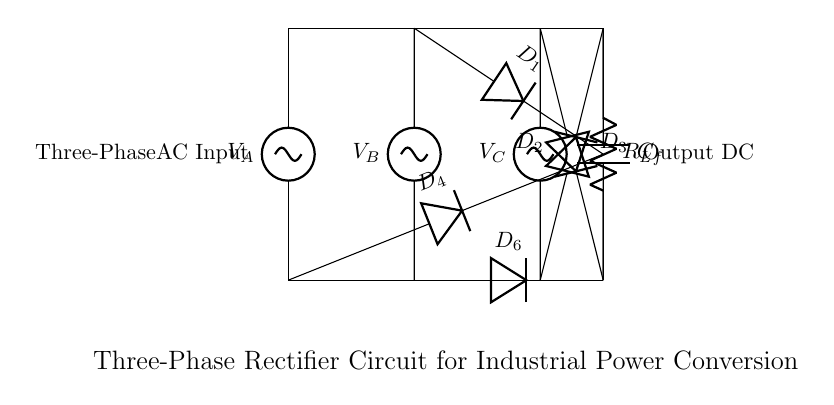What kind of input does this circuit use? The circuit uses a three-phase AC input, as indicated by the three voltage sources labeled V_A, V_B, and V_C.
Answer: three-phase AC input How many diodes are in the circuit? There are six diodes present in the diagram, labeled D_1, D_2, D_3, D_4, D_5, and D_6.
Answer: six diodes What is the primary function of this circuit? The primary function of this circuit is to convert three-phase AC power into DC using a diode bridge rectifier.
Answer: convert AC to DC What is the output component used in this circuit? The output components include a resistor labeled R_L and a capacitor labeled C_f, which are used to filter and deliver the rectified DC voltage.
Answer: R_L and C_f Which diode is connected to the AC input V_B? The diode connected to the AC input V_B is labeled D_1 and D_6. D_1 connects the positive side and D_6 connects the negative side.
Answer: D_1 and D_6 What type of circuit is represented by this diagram? This is a three-phase rectifier circuit, specifically designed for industrial power conversion applications by utilizing three-phase input.
Answer: three-phase rectifier What role does the capacitor C_f play in this circuit? The capacitor C_f acts as a filter to smooth out the rectified DC output by reducing voltage ripple, ensuring a more stable DC output.
Answer: smoothing the output 